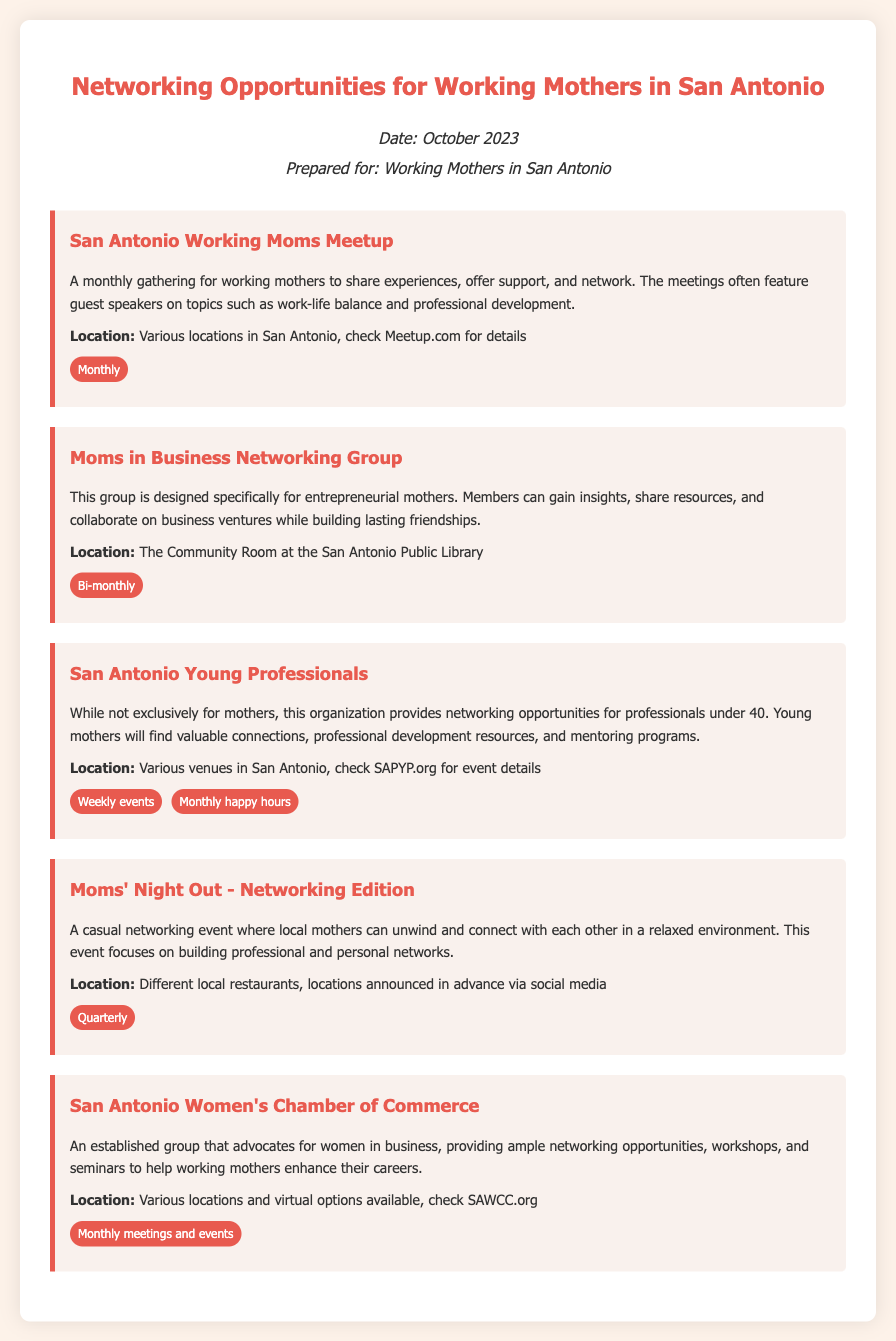What is the name of the networking group for entrepreneurial mothers? The document lists the "Moms in Business Networking Group" as a networking group specifically for entrepreneurial mothers.
Answer: Moms in Business Networking Group How often does the San Antonio Working Moms Meetup occur? The frequency of the San Antonio Working Moms Meetup is specified in the document as "Monthly."
Answer: Monthly Where does the San Antonio Young Professionals organization host events? The document indicates that events are hosted at "Various venues in San Antonio."
Answer: Various venues in San Antonio What is the tag associated with the Moms' Night Out - Networking Edition? The document notes that the frequency tag for this event is "Quarterly."
Answer: Quarterly What is the primary focus of the San Antonio Women's Chamber of Commerce? The document explains that it advocates for women in business and provides networking opportunities and workshops.
Answer: Advocate for women in business How does the Moms in Business Networking Group help its members? The document states that this group helps members gain insights, share resources, and collaborate while building friendships.
Answer: Gain insights, share resources, collaborate What type of events does the San Antonio Young Professionals host? The document mentions both "Weekly events" and "Monthly happy hours" for this organization.
Answer: Weekly events, Monthly happy hours How can one find details about the San Antonio Working Moms Meetup locations? According to the document, details about locations can be found on "Meetup.com."
Answer: Meetup.com 